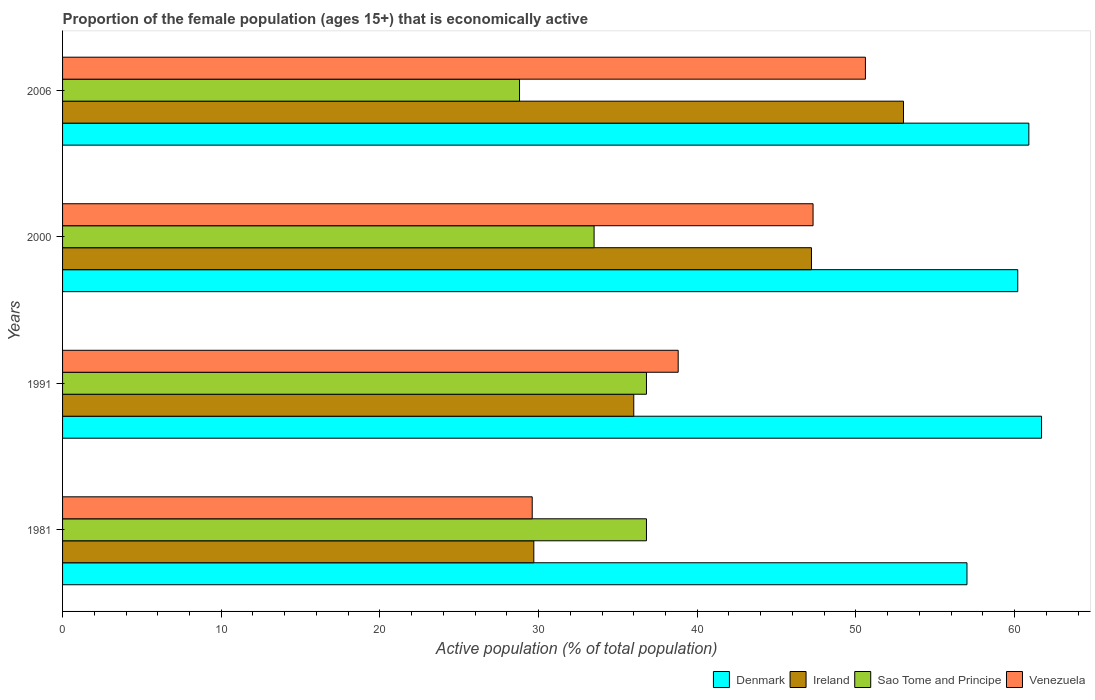Are the number of bars per tick equal to the number of legend labels?
Provide a succinct answer. Yes. What is the label of the 1st group of bars from the top?
Give a very brief answer. 2006. In how many cases, is the number of bars for a given year not equal to the number of legend labels?
Provide a succinct answer. 0. What is the proportion of the female population that is economically active in Venezuela in 1991?
Make the answer very short. 38.8. Across all years, what is the maximum proportion of the female population that is economically active in Denmark?
Provide a short and direct response. 61.7. Across all years, what is the minimum proportion of the female population that is economically active in Sao Tome and Principe?
Give a very brief answer. 28.8. In which year was the proportion of the female population that is economically active in Venezuela maximum?
Offer a terse response. 2006. What is the total proportion of the female population that is economically active in Denmark in the graph?
Offer a terse response. 239.8. What is the difference between the proportion of the female population that is economically active in Denmark in 1981 and that in 1991?
Your answer should be very brief. -4.7. What is the difference between the proportion of the female population that is economically active in Sao Tome and Principe in 2006 and the proportion of the female population that is economically active in Ireland in 2000?
Your answer should be compact. -18.4. What is the average proportion of the female population that is economically active in Ireland per year?
Your answer should be very brief. 41.48. In the year 2006, what is the difference between the proportion of the female population that is economically active in Venezuela and proportion of the female population that is economically active in Sao Tome and Principe?
Provide a succinct answer. 21.8. In how many years, is the proportion of the female population that is economically active in Venezuela greater than 54 %?
Your answer should be very brief. 0. What is the ratio of the proportion of the female population that is economically active in Ireland in 1981 to that in 2000?
Offer a very short reply. 0.63. What is the difference between the highest and the lowest proportion of the female population that is economically active in Sao Tome and Principe?
Your answer should be compact. 8. In how many years, is the proportion of the female population that is economically active in Sao Tome and Principe greater than the average proportion of the female population that is economically active in Sao Tome and Principe taken over all years?
Your answer should be very brief. 2. Is the sum of the proportion of the female population that is economically active in Denmark in 2000 and 2006 greater than the maximum proportion of the female population that is economically active in Venezuela across all years?
Your response must be concise. Yes. Is it the case that in every year, the sum of the proportion of the female population that is economically active in Ireland and proportion of the female population that is economically active in Denmark is greater than the sum of proportion of the female population that is economically active in Venezuela and proportion of the female population that is economically active in Sao Tome and Principe?
Provide a short and direct response. Yes. Is it the case that in every year, the sum of the proportion of the female population that is economically active in Sao Tome and Principe and proportion of the female population that is economically active in Ireland is greater than the proportion of the female population that is economically active in Denmark?
Ensure brevity in your answer.  Yes. Are all the bars in the graph horizontal?
Offer a very short reply. Yes. What is the difference between two consecutive major ticks on the X-axis?
Your response must be concise. 10. Are the values on the major ticks of X-axis written in scientific E-notation?
Your answer should be compact. No. Does the graph contain grids?
Ensure brevity in your answer.  No. Where does the legend appear in the graph?
Your answer should be very brief. Bottom right. How are the legend labels stacked?
Make the answer very short. Horizontal. What is the title of the graph?
Give a very brief answer. Proportion of the female population (ages 15+) that is economically active. What is the label or title of the X-axis?
Ensure brevity in your answer.  Active population (% of total population). What is the Active population (% of total population) of Ireland in 1981?
Keep it short and to the point. 29.7. What is the Active population (% of total population) in Sao Tome and Principe in 1981?
Provide a short and direct response. 36.8. What is the Active population (% of total population) in Venezuela in 1981?
Provide a short and direct response. 29.6. What is the Active population (% of total population) in Denmark in 1991?
Give a very brief answer. 61.7. What is the Active population (% of total population) in Sao Tome and Principe in 1991?
Ensure brevity in your answer.  36.8. What is the Active population (% of total population) of Venezuela in 1991?
Offer a terse response. 38.8. What is the Active population (% of total population) in Denmark in 2000?
Offer a very short reply. 60.2. What is the Active population (% of total population) in Ireland in 2000?
Ensure brevity in your answer.  47.2. What is the Active population (% of total population) in Sao Tome and Principe in 2000?
Offer a terse response. 33.5. What is the Active population (% of total population) in Venezuela in 2000?
Your answer should be compact. 47.3. What is the Active population (% of total population) of Denmark in 2006?
Keep it short and to the point. 60.9. What is the Active population (% of total population) in Sao Tome and Principe in 2006?
Offer a terse response. 28.8. What is the Active population (% of total population) in Venezuela in 2006?
Offer a very short reply. 50.6. Across all years, what is the maximum Active population (% of total population) in Denmark?
Your response must be concise. 61.7. Across all years, what is the maximum Active population (% of total population) in Sao Tome and Principe?
Offer a terse response. 36.8. Across all years, what is the maximum Active population (% of total population) of Venezuela?
Your answer should be very brief. 50.6. Across all years, what is the minimum Active population (% of total population) in Denmark?
Your answer should be compact. 57. Across all years, what is the minimum Active population (% of total population) of Ireland?
Make the answer very short. 29.7. Across all years, what is the minimum Active population (% of total population) of Sao Tome and Principe?
Provide a succinct answer. 28.8. Across all years, what is the minimum Active population (% of total population) in Venezuela?
Offer a terse response. 29.6. What is the total Active population (% of total population) of Denmark in the graph?
Your response must be concise. 239.8. What is the total Active population (% of total population) of Ireland in the graph?
Offer a very short reply. 165.9. What is the total Active population (% of total population) of Sao Tome and Principe in the graph?
Give a very brief answer. 135.9. What is the total Active population (% of total population) in Venezuela in the graph?
Provide a short and direct response. 166.3. What is the difference between the Active population (% of total population) of Denmark in 1981 and that in 1991?
Your response must be concise. -4.7. What is the difference between the Active population (% of total population) in Ireland in 1981 and that in 2000?
Keep it short and to the point. -17.5. What is the difference between the Active population (% of total population) in Sao Tome and Principe in 1981 and that in 2000?
Your answer should be compact. 3.3. What is the difference between the Active population (% of total population) of Venezuela in 1981 and that in 2000?
Offer a very short reply. -17.7. What is the difference between the Active population (% of total population) in Ireland in 1981 and that in 2006?
Your answer should be compact. -23.3. What is the difference between the Active population (% of total population) in Venezuela in 1981 and that in 2006?
Give a very brief answer. -21. What is the difference between the Active population (% of total population) in Sao Tome and Principe in 1991 and that in 2000?
Offer a terse response. 3.3. What is the difference between the Active population (% of total population) in Denmark in 1981 and the Active population (% of total population) in Ireland in 1991?
Your answer should be very brief. 21. What is the difference between the Active population (% of total population) in Denmark in 1981 and the Active population (% of total population) in Sao Tome and Principe in 1991?
Your answer should be very brief. 20.2. What is the difference between the Active population (% of total population) in Ireland in 1981 and the Active population (% of total population) in Sao Tome and Principe in 1991?
Keep it short and to the point. -7.1. What is the difference between the Active population (% of total population) of Ireland in 1981 and the Active population (% of total population) of Venezuela in 1991?
Provide a short and direct response. -9.1. What is the difference between the Active population (% of total population) of Denmark in 1981 and the Active population (% of total population) of Ireland in 2000?
Your response must be concise. 9.8. What is the difference between the Active population (% of total population) in Denmark in 1981 and the Active population (% of total population) in Sao Tome and Principe in 2000?
Offer a very short reply. 23.5. What is the difference between the Active population (% of total population) in Ireland in 1981 and the Active population (% of total population) in Venezuela in 2000?
Your answer should be very brief. -17.6. What is the difference between the Active population (% of total population) of Denmark in 1981 and the Active population (% of total population) of Sao Tome and Principe in 2006?
Keep it short and to the point. 28.2. What is the difference between the Active population (% of total population) in Ireland in 1981 and the Active population (% of total population) in Venezuela in 2006?
Offer a very short reply. -20.9. What is the difference between the Active population (% of total population) of Denmark in 1991 and the Active population (% of total population) of Sao Tome and Principe in 2000?
Ensure brevity in your answer.  28.2. What is the difference between the Active population (% of total population) of Ireland in 1991 and the Active population (% of total population) of Sao Tome and Principe in 2000?
Your answer should be very brief. 2.5. What is the difference between the Active population (% of total population) in Ireland in 1991 and the Active population (% of total population) in Venezuela in 2000?
Offer a very short reply. -11.3. What is the difference between the Active population (% of total population) of Sao Tome and Principe in 1991 and the Active population (% of total population) of Venezuela in 2000?
Make the answer very short. -10.5. What is the difference between the Active population (% of total population) of Denmark in 1991 and the Active population (% of total population) of Sao Tome and Principe in 2006?
Provide a short and direct response. 32.9. What is the difference between the Active population (% of total population) of Denmark in 1991 and the Active population (% of total population) of Venezuela in 2006?
Your answer should be compact. 11.1. What is the difference between the Active population (% of total population) in Ireland in 1991 and the Active population (% of total population) in Venezuela in 2006?
Keep it short and to the point. -14.6. What is the difference between the Active population (% of total population) of Denmark in 2000 and the Active population (% of total population) of Ireland in 2006?
Provide a short and direct response. 7.2. What is the difference between the Active population (% of total population) in Denmark in 2000 and the Active population (% of total population) in Sao Tome and Principe in 2006?
Keep it short and to the point. 31.4. What is the difference between the Active population (% of total population) in Denmark in 2000 and the Active population (% of total population) in Venezuela in 2006?
Your answer should be very brief. 9.6. What is the difference between the Active population (% of total population) of Ireland in 2000 and the Active population (% of total population) of Sao Tome and Principe in 2006?
Ensure brevity in your answer.  18.4. What is the difference between the Active population (% of total population) of Ireland in 2000 and the Active population (% of total population) of Venezuela in 2006?
Make the answer very short. -3.4. What is the difference between the Active population (% of total population) of Sao Tome and Principe in 2000 and the Active population (% of total population) of Venezuela in 2006?
Give a very brief answer. -17.1. What is the average Active population (% of total population) of Denmark per year?
Offer a terse response. 59.95. What is the average Active population (% of total population) in Ireland per year?
Offer a very short reply. 41.48. What is the average Active population (% of total population) in Sao Tome and Principe per year?
Your answer should be very brief. 33.98. What is the average Active population (% of total population) in Venezuela per year?
Offer a terse response. 41.58. In the year 1981, what is the difference between the Active population (% of total population) in Denmark and Active population (% of total population) in Ireland?
Make the answer very short. 27.3. In the year 1981, what is the difference between the Active population (% of total population) in Denmark and Active population (% of total population) in Sao Tome and Principe?
Provide a succinct answer. 20.2. In the year 1981, what is the difference between the Active population (% of total population) of Denmark and Active population (% of total population) of Venezuela?
Keep it short and to the point. 27.4. In the year 1981, what is the difference between the Active population (% of total population) in Ireland and Active population (% of total population) in Sao Tome and Principe?
Ensure brevity in your answer.  -7.1. In the year 1991, what is the difference between the Active population (% of total population) in Denmark and Active population (% of total population) in Ireland?
Your answer should be compact. 25.7. In the year 1991, what is the difference between the Active population (% of total population) in Denmark and Active population (% of total population) in Sao Tome and Principe?
Offer a terse response. 24.9. In the year 1991, what is the difference between the Active population (% of total population) in Denmark and Active population (% of total population) in Venezuela?
Offer a very short reply. 22.9. In the year 1991, what is the difference between the Active population (% of total population) in Ireland and Active population (% of total population) in Sao Tome and Principe?
Offer a very short reply. -0.8. In the year 2000, what is the difference between the Active population (% of total population) of Denmark and Active population (% of total population) of Sao Tome and Principe?
Your response must be concise. 26.7. In the year 2000, what is the difference between the Active population (% of total population) in Ireland and Active population (% of total population) in Sao Tome and Principe?
Offer a very short reply. 13.7. In the year 2000, what is the difference between the Active population (% of total population) of Ireland and Active population (% of total population) of Venezuela?
Ensure brevity in your answer.  -0.1. In the year 2006, what is the difference between the Active population (% of total population) of Denmark and Active population (% of total population) of Sao Tome and Principe?
Offer a terse response. 32.1. In the year 2006, what is the difference between the Active population (% of total population) of Denmark and Active population (% of total population) of Venezuela?
Make the answer very short. 10.3. In the year 2006, what is the difference between the Active population (% of total population) in Ireland and Active population (% of total population) in Sao Tome and Principe?
Make the answer very short. 24.2. In the year 2006, what is the difference between the Active population (% of total population) of Ireland and Active population (% of total population) of Venezuela?
Your response must be concise. 2.4. In the year 2006, what is the difference between the Active population (% of total population) of Sao Tome and Principe and Active population (% of total population) of Venezuela?
Your answer should be compact. -21.8. What is the ratio of the Active population (% of total population) of Denmark in 1981 to that in 1991?
Your answer should be very brief. 0.92. What is the ratio of the Active population (% of total population) in Ireland in 1981 to that in 1991?
Keep it short and to the point. 0.82. What is the ratio of the Active population (% of total population) of Sao Tome and Principe in 1981 to that in 1991?
Make the answer very short. 1. What is the ratio of the Active population (% of total population) in Venezuela in 1981 to that in 1991?
Your answer should be compact. 0.76. What is the ratio of the Active population (% of total population) of Denmark in 1981 to that in 2000?
Give a very brief answer. 0.95. What is the ratio of the Active population (% of total population) of Ireland in 1981 to that in 2000?
Provide a succinct answer. 0.63. What is the ratio of the Active population (% of total population) in Sao Tome and Principe in 1981 to that in 2000?
Provide a succinct answer. 1.1. What is the ratio of the Active population (% of total population) in Venezuela in 1981 to that in 2000?
Ensure brevity in your answer.  0.63. What is the ratio of the Active population (% of total population) in Denmark in 1981 to that in 2006?
Your response must be concise. 0.94. What is the ratio of the Active population (% of total population) of Ireland in 1981 to that in 2006?
Offer a very short reply. 0.56. What is the ratio of the Active population (% of total population) of Sao Tome and Principe in 1981 to that in 2006?
Ensure brevity in your answer.  1.28. What is the ratio of the Active population (% of total population) in Venezuela in 1981 to that in 2006?
Your answer should be very brief. 0.58. What is the ratio of the Active population (% of total population) of Denmark in 1991 to that in 2000?
Make the answer very short. 1.02. What is the ratio of the Active population (% of total population) in Ireland in 1991 to that in 2000?
Ensure brevity in your answer.  0.76. What is the ratio of the Active population (% of total population) in Sao Tome and Principe in 1991 to that in 2000?
Provide a short and direct response. 1.1. What is the ratio of the Active population (% of total population) of Venezuela in 1991 to that in 2000?
Keep it short and to the point. 0.82. What is the ratio of the Active population (% of total population) of Denmark in 1991 to that in 2006?
Provide a succinct answer. 1.01. What is the ratio of the Active population (% of total population) of Ireland in 1991 to that in 2006?
Your answer should be compact. 0.68. What is the ratio of the Active population (% of total population) of Sao Tome and Principe in 1991 to that in 2006?
Provide a short and direct response. 1.28. What is the ratio of the Active population (% of total population) in Venezuela in 1991 to that in 2006?
Give a very brief answer. 0.77. What is the ratio of the Active population (% of total population) in Ireland in 2000 to that in 2006?
Provide a short and direct response. 0.89. What is the ratio of the Active population (% of total population) in Sao Tome and Principe in 2000 to that in 2006?
Keep it short and to the point. 1.16. What is the ratio of the Active population (% of total population) of Venezuela in 2000 to that in 2006?
Provide a succinct answer. 0.93. What is the difference between the highest and the second highest Active population (% of total population) of Ireland?
Provide a succinct answer. 5.8. What is the difference between the highest and the second highest Active population (% of total population) of Sao Tome and Principe?
Your answer should be compact. 0. What is the difference between the highest and the lowest Active population (% of total population) in Ireland?
Your answer should be compact. 23.3. What is the difference between the highest and the lowest Active population (% of total population) of Venezuela?
Ensure brevity in your answer.  21. 